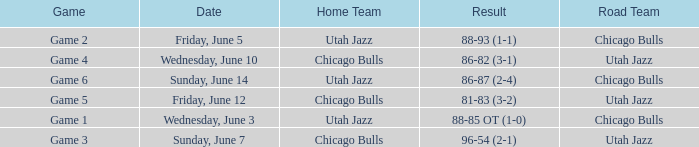Which game had an outcome of 86-87 (2-4)? Game 6. 